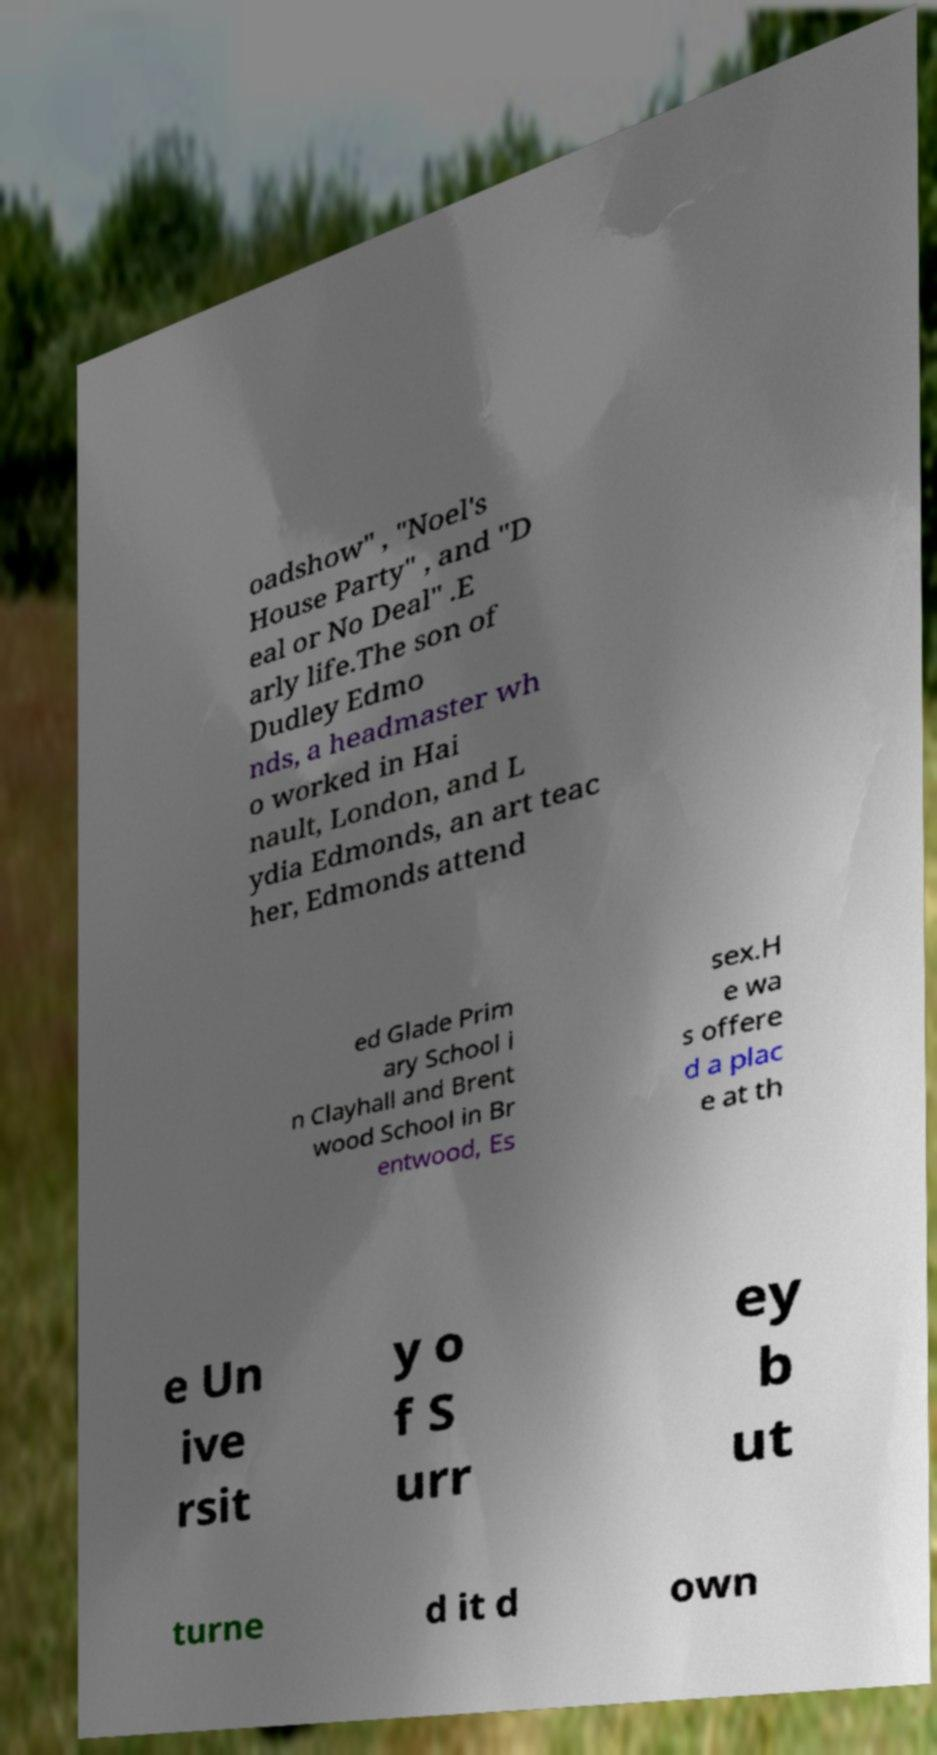Can you accurately transcribe the text from the provided image for me? oadshow" , "Noel's House Party" , and "D eal or No Deal" .E arly life.The son of Dudley Edmo nds, a headmaster wh o worked in Hai nault, London, and L ydia Edmonds, an art teac her, Edmonds attend ed Glade Prim ary School i n Clayhall and Brent wood School in Br entwood, Es sex.H e wa s offere d a plac e at th e Un ive rsit y o f S urr ey b ut turne d it d own 